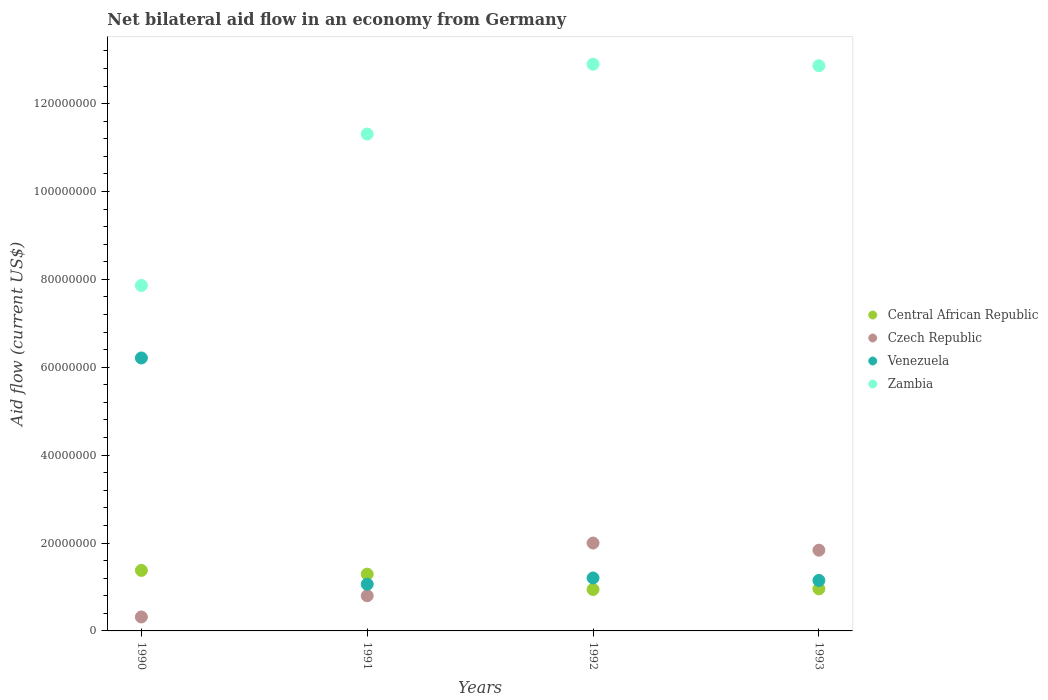How many different coloured dotlines are there?
Ensure brevity in your answer.  4. What is the net bilateral aid flow in Central African Republic in 1990?
Keep it short and to the point. 1.38e+07. Across all years, what is the maximum net bilateral aid flow in Central African Republic?
Ensure brevity in your answer.  1.38e+07. Across all years, what is the minimum net bilateral aid flow in Venezuela?
Your response must be concise. 1.06e+07. In which year was the net bilateral aid flow in Central African Republic maximum?
Offer a very short reply. 1990. What is the total net bilateral aid flow in Zambia in the graph?
Your response must be concise. 4.49e+08. What is the difference between the net bilateral aid flow in Zambia in 1990 and that in 1993?
Keep it short and to the point. -5.00e+07. What is the difference between the net bilateral aid flow in Zambia in 1991 and the net bilateral aid flow in Czech Republic in 1992?
Offer a very short reply. 9.31e+07. What is the average net bilateral aid flow in Venezuela per year?
Keep it short and to the point. 2.41e+07. In the year 1993, what is the difference between the net bilateral aid flow in Czech Republic and net bilateral aid flow in Central African Republic?
Provide a succinct answer. 8.80e+06. In how many years, is the net bilateral aid flow in Czech Republic greater than 76000000 US$?
Your answer should be compact. 0. What is the ratio of the net bilateral aid flow in Zambia in 1990 to that in 1993?
Keep it short and to the point. 0.61. What is the difference between the highest and the second highest net bilateral aid flow in Czech Republic?
Keep it short and to the point. 1.63e+06. What is the difference between the highest and the lowest net bilateral aid flow in Czech Republic?
Offer a very short reply. 1.68e+07. In how many years, is the net bilateral aid flow in Venezuela greater than the average net bilateral aid flow in Venezuela taken over all years?
Offer a terse response. 1. Is the sum of the net bilateral aid flow in Venezuela in 1990 and 1992 greater than the maximum net bilateral aid flow in Central African Republic across all years?
Offer a terse response. Yes. Is it the case that in every year, the sum of the net bilateral aid flow in Zambia and net bilateral aid flow in Central African Republic  is greater than the sum of net bilateral aid flow in Czech Republic and net bilateral aid flow in Venezuela?
Provide a succinct answer. Yes. Is it the case that in every year, the sum of the net bilateral aid flow in Czech Republic and net bilateral aid flow in Zambia  is greater than the net bilateral aid flow in Venezuela?
Your answer should be compact. Yes. Does the net bilateral aid flow in Central African Republic monotonically increase over the years?
Provide a short and direct response. No. How many legend labels are there?
Give a very brief answer. 4. What is the title of the graph?
Provide a succinct answer. Net bilateral aid flow in an economy from Germany. What is the label or title of the X-axis?
Offer a terse response. Years. What is the label or title of the Y-axis?
Keep it short and to the point. Aid flow (current US$). What is the Aid flow (current US$) of Central African Republic in 1990?
Offer a very short reply. 1.38e+07. What is the Aid flow (current US$) in Czech Republic in 1990?
Keep it short and to the point. 3.18e+06. What is the Aid flow (current US$) of Venezuela in 1990?
Make the answer very short. 6.21e+07. What is the Aid flow (current US$) in Zambia in 1990?
Make the answer very short. 7.86e+07. What is the Aid flow (current US$) of Central African Republic in 1991?
Offer a terse response. 1.29e+07. What is the Aid flow (current US$) in Czech Republic in 1991?
Your response must be concise. 8.00e+06. What is the Aid flow (current US$) of Venezuela in 1991?
Provide a succinct answer. 1.06e+07. What is the Aid flow (current US$) of Zambia in 1991?
Make the answer very short. 1.13e+08. What is the Aid flow (current US$) in Central African Republic in 1992?
Give a very brief answer. 9.43e+06. What is the Aid flow (current US$) of Venezuela in 1992?
Your response must be concise. 1.20e+07. What is the Aid flow (current US$) of Zambia in 1992?
Offer a very short reply. 1.29e+08. What is the Aid flow (current US$) in Central African Republic in 1993?
Your answer should be compact. 9.57e+06. What is the Aid flow (current US$) in Czech Republic in 1993?
Make the answer very short. 1.84e+07. What is the Aid flow (current US$) of Venezuela in 1993?
Give a very brief answer. 1.15e+07. What is the Aid flow (current US$) of Zambia in 1993?
Your answer should be very brief. 1.29e+08. Across all years, what is the maximum Aid flow (current US$) of Central African Republic?
Provide a succinct answer. 1.38e+07. Across all years, what is the maximum Aid flow (current US$) in Czech Republic?
Offer a terse response. 2.00e+07. Across all years, what is the maximum Aid flow (current US$) of Venezuela?
Provide a succinct answer. 6.21e+07. Across all years, what is the maximum Aid flow (current US$) of Zambia?
Provide a short and direct response. 1.29e+08. Across all years, what is the minimum Aid flow (current US$) of Central African Republic?
Provide a short and direct response. 9.43e+06. Across all years, what is the minimum Aid flow (current US$) of Czech Republic?
Make the answer very short. 3.18e+06. Across all years, what is the minimum Aid flow (current US$) in Venezuela?
Offer a very short reply. 1.06e+07. Across all years, what is the minimum Aid flow (current US$) of Zambia?
Keep it short and to the point. 7.86e+07. What is the total Aid flow (current US$) in Central African Republic in the graph?
Give a very brief answer. 4.57e+07. What is the total Aid flow (current US$) in Czech Republic in the graph?
Provide a short and direct response. 4.96e+07. What is the total Aid flow (current US$) in Venezuela in the graph?
Your answer should be very brief. 9.63e+07. What is the total Aid flow (current US$) in Zambia in the graph?
Provide a succinct answer. 4.49e+08. What is the difference between the Aid flow (current US$) in Central African Republic in 1990 and that in 1991?
Give a very brief answer. 8.50e+05. What is the difference between the Aid flow (current US$) of Czech Republic in 1990 and that in 1991?
Keep it short and to the point. -4.82e+06. What is the difference between the Aid flow (current US$) in Venezuela in 1990 and that in 1991?
Provide a short and direct response. 5.15e+07. What is the difference between the Aid flow (current US$) in Zambia in 1990 and that in 1991?
Your answer should be very brief. -3.45e+07. What is the difference between the Aid flow (current US$) in Central African Republic in 1990 and that in 1992?
Provide a short and direct response. 4.34e+06. What is the difference between the Aid flow (current US$) of Czech Republic in 1990 and that in 1992?
Your answer should be compact. -1.68e+07. What is the difference between the Aid flow (current US$) of Venezuela in 1990 and that in 1992?
Ensure brevity in your answer.  5.01e+07. What is the difference between the Aid flow (current US$) in Zambia in 1990 and that in 1992?
Ensure brevity in your answer.  -5.04e+07. What is the difference between the Aid flow (current US$) in Central African Republic in 1990 and that in 1993?
Offer a very short reply. 4.20e+06. What is the difference between the Aid flow (current US$) of Czech Republic in 1990 and that in 1993?
Give a very brief answer. -1.52e+07. What is the difference between the Aid flow (current US$) of Venezuela in 1990 and that in 1993?
Provide a succinct answer. 5.06e+07. What is the difference between the Aid flow (current US$) of Zambia in 1990 and that in 1993?
Ensure brevity in your answer.  -5.00e+07. What is the difference between the Aid flow (current US$) in Central African Republic in 1991 and that in 1992?
Provide a short and direct response. 3.49e+06. What is the difference between the Aid flow (current US$) in Czech Republic in 1991 and that in 1992?
Offer a terse response. -1.20e+07. What is the difference between the Aid flow (current US$) of Venezuela in 1991 and that in 1992?
Provide a short and direct response. -1.42e+06. What is the difference between the Aid flow (current US$) of Zambia in 1991 and that in 1992?
Your answer should be very brief. -1.59e+07. What is the difference between the Aid flow (current US$) of Central African Republic in 1991 and that in 1993?
Your answer should be very brief. 3.35e+06. What is the difference between the Aid flow (current US$) of Czech Republic in 1991 and that in 1993?
Ensure brevity in your answer.  -1.04e+07. What is the difference between the Aid flow (current US$) in Venezuela in 1991 and that in 1993?
Provide a succinct answer. -8.60e+05. What is the difference between the Aid flow (current US$) of Zambia in 1991 and that in 1993?
Provide a short and direct response. -1.56e+07. What is the difference between the Aid flow (current US$) of Central African Republic in 1992 and that in 1993?
Ensure brevity in your answer.  -1.40e+05. What is the difference between the Aid flow (current US$) in Czech Republic in 1992 and that in 1993?
Your answer should be compact. 1.63e+06. What is the difference between the Aid flow (current US$) in Venezuela in 1992 and that in 1993?
Your answer should be compact. 5.60e+05. What is the difference between the Aid flow (current US$) in Zambia in 1992 and that in 1993?
Make the answer very short. 3.40e+05. What is the difference between the Aid flow (current US$) in Central African Republic in 1990 and the Aid flow (current US$) in Czech Republic in 1991?
Offer a very short reply. 5.77e+06. What is the difference between the Aid flow (current US$) of Central African Republic in 1990 and the Aid flow (current US$) of Venezuela in 1991?
Keep it short and to the point. 3.14e+06. What is the difference between the Aid flow (current US$) in Central African Republic in 1990 and the Aid flow (current US$) in Zambia in 1991?
Offer a terse response. -9.93e+07. What is the difference between the Aid flow (current US$) of Czech Republic in 1990 and the Aid flow (current US$) of Venezuela in 1991?
Provide a short and direct response. -7.45e+06. What is the difference between the Aid flow (current US$) in Czech Republic in 1990 and the Aid flow (current US$) in Zambia in 1991?
Provide a succinct answer. -1.10e+08. What is the difference between the Aid flow (current US$) of Venezuela in 1990 and the Aid flow (current US$) of Zambia in 1991?
Offer a very short reply. -5.10e+07. What is the difference between the Aid flow (current US$) in Central African Republic in 1990 and the Aid flow (current US$) in Czech Republic in 1992?
Make the answer very short. -6.23e+06. What is the difference between the Aid flow (current US$) of Central African Republic in 1990 and the Aid flow (current US$) of Venezuela in 1992?
Keep it short and to the point. 1.72e+06. What is the difference between the Aid flow (current US$) in Central African Republic in 1990 and the Aid flow (current US$) in Zambia in 1992?
Provide a succinct answer. -1.15e+08. What is the difference between the Aid flow (current US$) of Czech Republic in 1990 and the Aid flow (current US$) of Venezuela in 1992?
Offer a terse response. -8.87e+06. What is the difference between the Aid flow (current US$) in Czech Republic in 1990 and the Aid flow (current US$) in Zambia in 1992?
Your answer should be compact. -1.26e+08. What is the difference between the Aid flow (current US$) in Venezuela in 1990 and the Aid flow (current US$) in Zambia in 1992?
Ensure brevity in your answer.  -6.68e+07. What is the difference between the Aid flow (current US$) in Central African Republic in 1990 and the Aid flow (current US$) in Czech Republic in 1993?
Your answer should be compact. -4.60e+06. What is the difference between the Aid flow (current US$) of Central African Republic in 1990 and the Aid flow (current US$) of Venezuela in 1993?
Provide a succinct answer. 2.28e+06. What is the difference between the Aid flow (current US$) in Central African Republic in 1990 and the Aid flow (current US$) in Zambia in 1993?
Provide a short and direct response. -1.15e+08. What is the difference between the Aid flow (current US$) in Czech Republic in 1990 and the Aid flow (current US$) in Venezuela in 1993?
Keep it short and to the point. -8.31e+06. What is the difference between the Aid flow (current US$) of Czech Republic in 1990 and the Aid flow (current US$) of Zambia in 1993?
Provide a succinct answer. -1.25e+08. What is the difference between the Aid flow (current US$) of Venezuela in 1990 and the Aid flow (current US$) of Zambia in 1993?
Offer a terse response. -6.65e+07. What is the difference between the Aid flow (current US$) in Central African Republic in 1991 and the Aid flow (current US$) in Czech Republic in 1992?
Your answer should be compact. -7.08e+06. What is the difference between the Aid flow (current US$) of Central African Republic in 1991 and the Aid flow (current US$) of Venezuela in 1992?
Ensure brevity in your answer.  8.70e+05. What is the difference between the Aid flow (current US$) in Central African Republic in 1991 and the Aid flow (current US$) in Zambia in 1992?
Your answer should be compact. -1.16e+08. What is the difference between the Aid flow (current US$) of Czech Republic in 1991 and the Aid flow (current US$) of Venezuela in 1992?
Give a very brief answer. -4.05e+06. What is the difference between the Aid flow (current US$) of Czech Republic in 1991 and the Aid flow (current US$) of Zambia in 1992?
Ensure brevity in your answer.  -1.21e+08. What is the difference between the Aid flow (current US$) in Venezuela in 1991 and the Aid flow (current US$) in Zambia in 1992?
Keep it short and to the point. -1.18e+08. What is the difference between the Aid flow (current US$) in Central African Republic in 1991 and the Aid flow (current US$) in Czech Republic in 1993?
Ensure brevity in your answer.  -5.45e+06. What is the difference between the Aid flow (current US$) in Central African Republic in 1991 and the Aid flow (current US$) in Venezuela in 1993?
Your answer should be compact. 1.43e+06. What is the difference between the Aid flow (current US$) in Central African Republic in 1991 and the Aid flow (current US$) in Zambia in 1993?
Keep it short and to the point. -1.16e+08. What is the difference between the Aid flow (current US$) of Czech Republic in 1991 and the Aid flow (current US$) of Venezuela in 1993?
Make the answer very short. -3.49e+06. What is the difference between the Aid flow (current US$) in Czech Republic in 1991 and the Aid flow (current US$) in Zambia in 1993?
Ensure brevity in your answer.  -1.21e+08. What is the difference between the Aid flow (current US$) of Venezuela in 1991 and the Aid flow (current US$) of Zambia in 1993?
Keep it short and to the point. -1.18e+08. What is the difference between the Aid flow (current US$) of Central African Republic in 1992 and the Aid flow (current US$) of Czech Republic in 1993?
Your answer should be compact. -8.94e+06. What is the difference between the Aid flow (current US$) of Central African Republic in 1992 and the Aid flow (current US$) of Venezuela in 1993?
Your response must be concise. -2.06e+06. What is the difference between the Aid flow (current US$) of Central African Republic in 1992 and the Aid flow (current US$) of Zambia in 1993?
Your response must be concise. -1.19e+08. What is the difference between the Aid flow (current US$) in Czech Republic in 1992 and the Aid flow (current US$) in Venezuela in 1993?
Offer a terse response. 8.51e+06. What is the difference between the Aid flow (current US$) in Czech Republic in 1992 and the Aid flow (current US$) in Zambia in 1993?
Your answer should be very brief. -1.09e+08. What is the difference between the Aid flow (current US$) in Venezuela in 1992 and the Aid flow (current US$) in Zambia in 1993?
Your answer should be compact. -1.17e+08. What is the average Aid flow (current US$) of Central African Republic per year?
Your response must be concise. 1.14e+07. What is the average Aid flow (current US$) of Czech Republic per year?
Your answer should be very brief. 1.24e+07. What is the average Aid flow (current US$) of Venezuela per year?
Provide a short and direct response. 2.41e+07. What is the average Aid flow (current US$) in Zambia per year?
Give a very brief answer. 1.12e+08. In the year 1990, what is the difference between the Aid flow (current US$) in Central African Republic and Aid flow (current US$) in Czech Republic?
Provide a short and direct response. 1.06e+07. In the year 1990, what is the difference between the Aid flow (current US$) in Central African Republic and Aid flow (current US$) in Venezuela?
Your answer should be very brief. -4.83e+07. In the year 1990, what is the difference between the Aid flow (current US$) in Central African Republic and Aid flow (current US$) in Zambia?
Ensure brevity in your answer.  -6.48e+07. In the year 1990, what is the difference between the Aid flow (current US$) in Czech Republic and Aid flow (current US$) in Venezuela?
Provide a succinct answer. -5.89e+07. In the year 1990, what is the difference between the Aid flow (current US$) of Czech Republic and Aid flow (current US$) of Zambia?
Provide a short and direct response. -7.54e+07. In the year 1990, what is the difference between the Aid flow (current US$) in Venezuela and Aid flow (current US$) in Zambia?
Provide a short and direct response. -1.65e+07. In the year 1991, what is the difference between the Aid flow (current US$) in Central African Republic and Aid flow (current US$) in Czech Republic?
Offer a very short reply. 4.92e+06. In the year 1991, what is the difference between the Aid flow (current US$) in Central African Republic and Aid flow (current US$) in Venezuela?
Your answer should be very brief. 2.29e+06. In the year 1991, what is the difference between the Aid flow (current US$) of Central African Republic and Aid flow (current US$) of Zambia?
Ensure brevity in your answer.  -1.00e+08. In the year 1991, what is the difference between the Aid flow (current US$) of Czech Republic and Aid flow (current US$) of Venezuela?
Offer a very short reply. -2.63e+06. In the year 1991, what is the difference between the Aid flow (current US$) in Czech Republic and Aid flow (current US$) in Zambia?
Your response must be concise. -1.05e+08. In the year 1991, what is the difference between the Aid flow (current US$) of Venezuela and Aid flow (current US$) of Zambia?
Give a very brief answer. -1.02e+08. In the year 1992, what is the difference between the Aid flow (current US$) in Central African Republic and Aid flow (current US$) in Czech Republic?
Your answer should be very brief. -1.06e+07. In the year 1992, what is the difference between the Aid flow (current US$) of Central African Republic and Aid flow (current US$) of Venezuela?
Your answer should be very brief. -2.62e+06. In the year 1992, what is the difference between the Aid flow (current US$) of Central African Republic and Aid flow (current US$) of Zambia?
Provide a short and direct response. -1.20e+08. In the year 1992, what is the difference between the Aid flow (current US$) of Czech Republic and Aid flow (current US$) of Venezuela?
Your answer should be very brief. 7.95e+06. In the year 1992, what is the difference between the Aid flow (current US$) of Czech Republic and Aid flow (current US$) of Zambia?
Offer a terse response. -1.09e+08. In the year 1992, what is the difference between the Aid flow (current US$) in Venezuela and Aid flow (current US$) in Zambia?
Provide a succinct answer. -1.17e+08. In the year 1993, what is the difference between the Aid flow (current US$) in Central African Republic and Aid flow (current US$) in Czech Republic?
Provide a succinct answer. -8.80e+06. In the year 1993, what is the difference between the Aid flow (current US$) of Central African Republic and Aid flow (current US$) of Venezuela?
Keep it short and to the point. -1.92e+06. In the year 1993, what is the difference between the Aid flow (current US$) of Central African Republic and Aid flow (current US$) of Zambia?
Your response must be concise. -1.19e+08. In the year 1993, what is the difference between the Aid flow (current US$) in Czech Republic and Aid flow (current US$) in Venezuela?
Ensure brevity in your answer.  6.88e+06. In the year 1993, what is the difference between the Aid flow (current US$) of Czech Republic and Aid flow (current US$) of Zambia?
Your answer should be compact. -1.10e+08. In the year 1993, what is the difference between the Aid flow (current US$) in Venezuela and Aid flow (current US$) in Zambia?
Give a very brief answer. -1.17e+08. What is the ratio of the Aid flow (current US$) of Central African Republic in 1990 to that in 1991?
Offer a terse response. 1.07. What is the ratio of the Aid flow (current US$) in Czech Republic in 1990 to that in 1991?
Your answer should be very brief. 0.4. What is the ratio of the Aid flow (current US$) in Venezuela in 1990 to that in 1991?
Your answer should be compact. 5.84. What is the ratio of the Aid flow (current US$) in Zambia in 1990 to that in 1991?
Make the answer very short. 0.7. What is the ratio of the Aid flow (current US$) of Central African Republic in 1990 to that in 1992?
Make the answer very short. 1.46. What is the ratio of the Aid flow (current US$) in Czech Republic in 1990 to that in 1992?
Offer a terse response. 0.16. What is the ratio of the Aid flow (current US$) of Venezuela in 1990 to that in 1992?
Provide a succinct answer. 5.15. What is the ratio of the Aid flow (current US$) of Zambia in 1990 to that in 1992?
Ensure brevity in your answer.  0.61. What is the ratio of the Aid flow (current US$) of Central African Republic in 1990 to that in 1993?
Your answer should be compact. 1.44. What is the ratio of the Aid flow (current US$) of Czech Republic in 1990 to that in 1993?
Your response must be concise. 0.17. What is the ratio of the Aid flow (current US$) of Venezuela in 1990 to that in 1993?
Make the answer very short. 5.41. What is the ratio of the Aid flow (current US$) in Zambia in 1990 to that in 1993?
Provide a short and direct response. 0.61. What is the ratio of the Aid flow (current US$) in Central African Republic in 1991 to that in 1992?
Your answer should be very brief. 1.37. What is the ratio of the Aid flow (current US$) of Czech Republic in 1991 to that in 1992?
Provide a short and direct response. 0.4. What is the ratio of the Aid flow (current US$) of Venezuela in 1991 to that in 1992?
Make the answer very short. 0.88. What is the ratio of the Aid flow (current US$) in Zambia in 1991 to that in 1992?
Your answer should be compact. 0.88. What is the ratio of the Aid flow (current US$) in Central African Republic in 1991 to that in 1993?
Ensure brevity in your answer.  1.35. What is the ratio of the Aid flow (current US$) of Czech Republic in 1991 to that in 1993?
Provide a succinct answer. 0.44. What is the ratio of the Aid flow (current US$) in Venezuela in 1991 to that in 1993?
Your response must be concise. 0.93. What is the ratio of the Aid flow (current US$) in Zambia in 1991 to that in 1993?
Offer a terse response. 0.88. What is the ratio of the Aid flow (current US$) in Central African Republic in 1992 to that in 1993?
Your answer should be compact. 0.99. What is the ratio of the Aid flow (current US$) of Czech Republic in 1992 to that in 1993?
Offer a very short reply. 1.09. What is the ratio of the Aid flow (current US$) in Venezuela in 1992 to that in 1993?
Provide a succinct answer. 1.05. What is the ratio of the Aid flow (current US$) in Zambia in 1992 to that in 1993?
Give a very brief answer. 1. What is the difference between the highest and the second highest Aid flow (current US$) of Central African Republic?
Provide a short and direct response. 8.50e+05. What is the difference between the highest and the second highest Aid flow (current US$) of Czech Republic?
Ensure brevity in your answer.  1.63e+06. What is the difference between the highest and the second highest Aid flow (current US$) in Venezuela?
Your answer should be compact. 5.01e+07. What is the difference between the highest and the second highest Aid flow (current US$) of Zambia?
Your answer should be very brief. 3.40e+05. What is the difference between the highest and the lowest Aid flow (current US$) of Central African Republic?
Make the answer very short. 4.34e+06. What is the difference between the highest and the lowest Aid flow (current US$) of Czech Republic?
Your response must be concise. 1.68e+07. What is the difference between the highest and the lowest Aid flow (current US$) of Venezuela?
Make the answer very short. 5.15e+07. What is the difference between the highest and the lowest Aid flow (current US$) of Zambia?
Provide a short and direct response. 5.04e+07. 